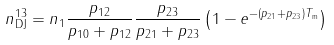Convert formula to latex. <formula><loc_0><loc_0><loc_500><loc_500>n _ { \text {DJ} } ^ { 1 3 } = n _ { 1 } \frac { p _ { 1 2 } } { p _ { 1 0 } + p _ { 1 2 } } \frac { p _ { 2 3 } } { p _ { 2 1 } + p _ { 2 3 } } \left ( 1 - e ^ { - ( p _ { 2 1 } + p _ { 2 3 } ) T _ { \text {m} } } \right )</formula> 